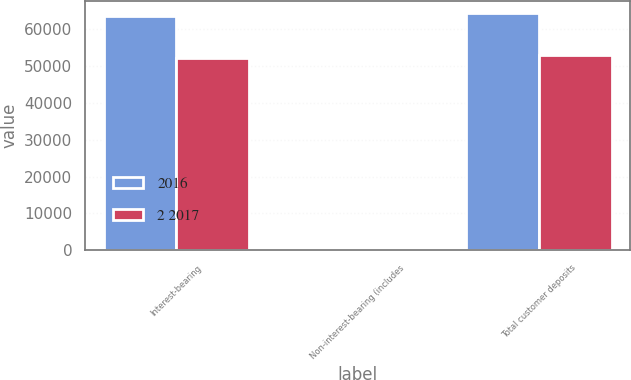Convert chart to OTSL. <chart><loc_0><loc_0><loc_500><loc_500><stacked_bar_chart><ecel><fcel>Interest-bearing<fcel>Non-interest-bearing (includes<fcel>Total customer deposits<nl><fcel>2016<fcel>63666<fcel>357<fcel>64452<nl><fcel>2 2017<fcel>52316<fcel>301<fcel>53042<nl></chart> 